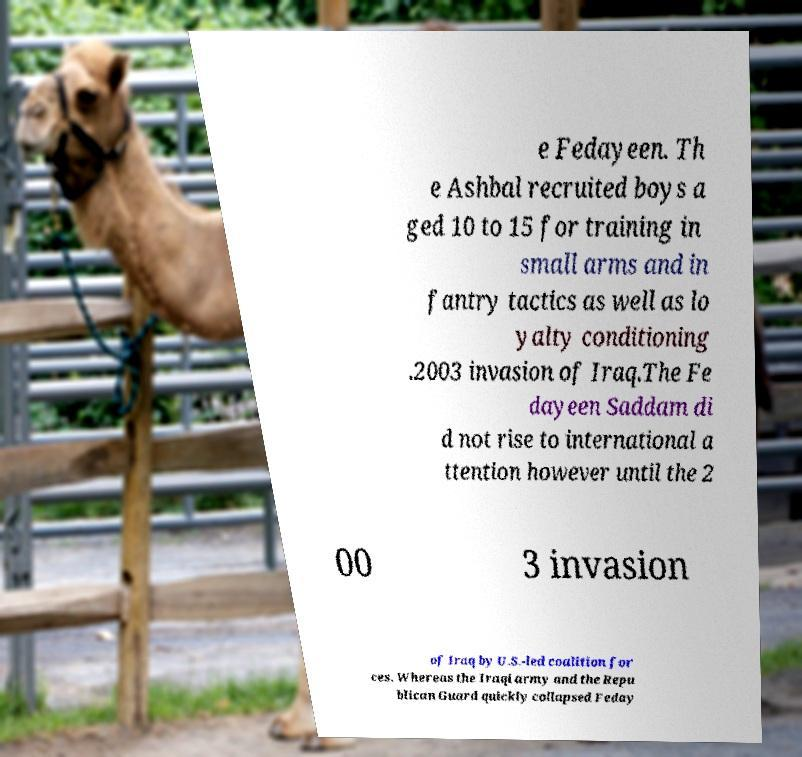For documentation purposes, I need the text within this image transcribed. Could you provide that? e Fedayeen. Th e Ashbal recruited boys a ged 10 to 15 for training in small arms and in fantry tactics as well as lo yalty conditioning .2003 invasion of Iraq.The Fe dayeen Saddam di d not rise to international a ttention however until the 2 00 3 invasion of Iraq by U.S.-led coalition for ces. Whereas the Iraqi army and the Repu blican Guard quickly collapsed Feday 